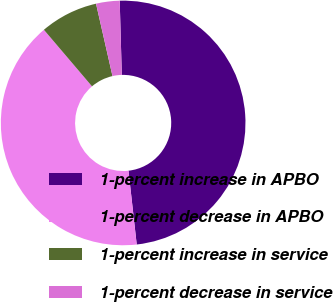Convert chart to OTSL. <chart><loc_0><loc_0><loc_500><loc_500><pie_chart><fcel>1-percent increase in APBO<fcel>1-percent decrease in APBO<fcel>1-percent increase in service<fcel>1-percent decrease in service<nl><fcel>48.68%<fcel>40.55%<fcel>7.66%<fcel>3.11%<nl></chart> 